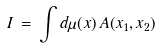Convert formula to latex. <formula><loc_0><loc_0><loc_500><loc_500>I \, = \, \int d \mu ( x ) \, A ( x _ { 1 } , x _ { 2 } )</formula> 